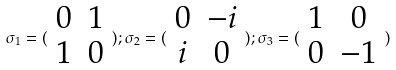Convert formula to latex. <formula><loc_0><loc_0><loc_500><loc_500>\sigma _ { 1 } = ( \begin{array} { c c } 0 & 1 \\ 1 & 0 \end{array} ) ; \sigma _ { 2 } = ( \begin{array} { c c } 0 & - i \\ i & 0 \end{array} ) ; \sigma _ { 3 } = ( \begin{array} { c c } 1 & 0 \\ 0 & - 1 \end{array} )</formula> 